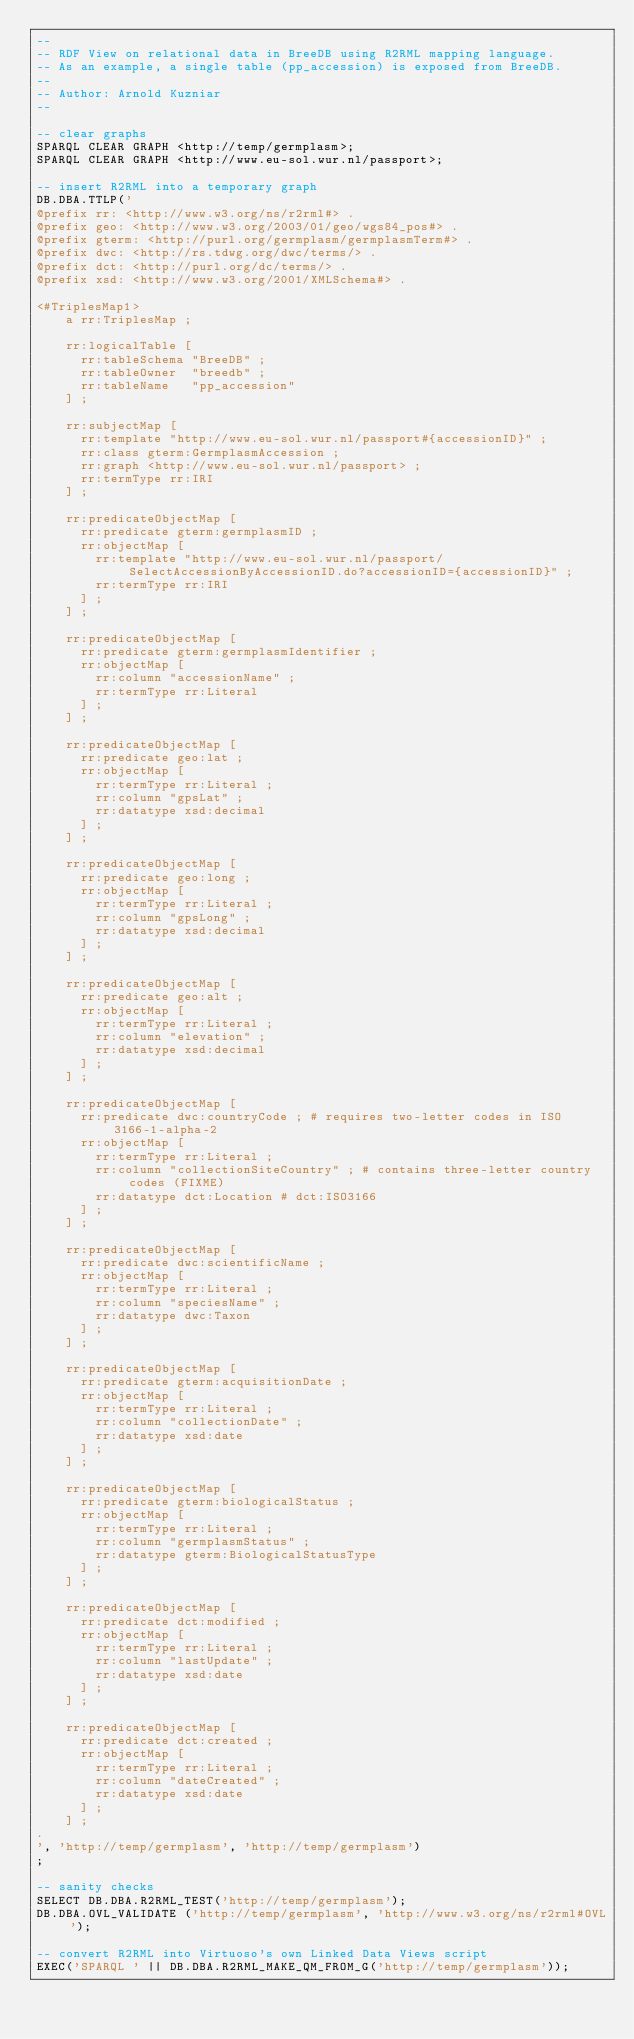Convert code to text. <code><loc_0><loc_0><loc_500><loc_500><_SQL_>--
-- RDF View on relational data in BreeDB using R2RML mapping language.
-- As an example, a single table (pp_accession) is exposed from BreeDB.
--
-- Author: Arnold Kuzniar
--

-- clear graphs
SPARQL CLEAR GRAPH <http://temp/germplasm>;
SPARQL CLEAR GRAPH <http://www.eu-sol.wur.nl/passport>;

-- insert R2RML into a temporary graph
DB.DBA.TTLP('
@prefix rr: <http://www.w3.org/ns/r2rml#> .
@prefix geo: <http://www.w3.org/2003/01/geo/wgs84_pos#> .
@prefix gterm: <http://purl.org/germplasm/germplasmTerm#> .
@prefix dwc: <http://rs.tdwg.org/dwc/terms/> .
@prefix dct: <http://purl.org/dc/terms/> .
@prefix xsd: <http://www.w3.org/2001/XMLSchema#> .

<#TriplesMap1>
    a rr:TriplesMap ;

    rr:logicalTable [
      rr:tableSchema "BreeDB" ;
      rr:tableOwner  "breedb" ;
      rr:tableName   "pp_accession"
    ] ;

    rr:subjectMap [
      rr:template "http://www.eu-sol.wur.nl/passport#{accessionID}" ;
      rr:class gterm:GermplasmAccession ;
      rr:graph <http://www.eu-sol.wur.nl/passport> ;
      rr:termType rr:IRI
    ] ;

    rr:predicateObjectMap [
      rr:predicate gterm:germplasmID ;
      rr:objectMap [
        rr:template "http://www.eu-sol.wur.nl/passport/SelectAccessionByAccessionID.do?accessionID={accessionID}" ;
        rr:termType rr:IRI
      ] ;
    ] ;

    rr:predicateObjectMap [
      rr:predicate gterm:germplasmIdentifier ;
      rr:objectMap [
        rr:column "accessionName" ;
        rr:termType rr:Literal
      ] ;
    ] ;

    rr:predicateObjectMap [
      rr:predicate geo:lat ;
      rr:objectMap [
        rr:termType rr:Literal ;
        rr:column "gpsLat" ;
        rr:datatype xsd:decimal
      ] ;
    ] ;

    rr:predicateObjectMap [
      rr:predicate geo:long ;
      rr:objectMap [
        rr:termType rr:Literal ;
        rr:column "gpsLong" ;
        rr:datatype xsd:decimal
      ] ;
    ] ;

    rr:predicateObjectMap [
      rr:predicate geo:alt ;
      rr:objectMap [
        rr:termType rr:Literal ;
        rr:column "elevation" ;
        rr:datatype xsd:decimal
      ] ;
    ] ;

    rr:predicateObjectMap [
      rr:predicate dwc:countryCode ; # requires two-letter codes in ISO 3166-1-alpha-2
      rr:objectMap [
        rr:termType rr:Literal ;
        rr:column "collectionSiteCountry" ; # contains three-letter country codes (FIXME)
        rr:datatype dct:Location # dct:ISO3166
      ] ;
    ] ;

    rr:predicateObjectMap [
      rr:predicate dwc:scientificName ;
      rr:objectMap [
        rr:termType rr:Literal ;
        rr:column "speciesName" ;
        rr:datatype dwc:Taxon
      ] ;
    ] ;

    rr:predicateObjectMap [
      rr:predicate gterm:acquisitionDate ;
      rr:objectMap [
        rr:termType rr:Literal ;
        rr:column "collectionDate" ;
        rr:datatype xsd:date
      ] ;
    ] ;

    rr:predicateObjectMap [
      rr:predicate gterm:biologicalStatus ;
      rr:objectMap [
        rr:termType rr:Literal ;
        rr:column "germplasmStatus" ;
        rr:datatype gterm:BiologicalStatusType
      ] ;
    ] ;

    rr:predicateObjectMap [
      rr:predicate dct:modified ;
      rr:objectMap [
        rr:termType rr:Literal ;
        rr:column "lastUpdate" ;
        rr:datatype xsd:date
      ] ;
    ] ;

    rr:predicateObjectMap [
      rr:predicate dct:created ;
      rr:objectMap [
        rr:termType rr:Literal ;
        rr:column "dateCreated" ;
        rr:datatype xsd:date
      ] ;
    ] ;
.
', 'http://temp/germplasm', 'http://temp/germplasm')
;

-- sanity checks
SELECT DB.DBA.R2RML_TEST('http://temp/germplasm');
DB.DBA.OVL_VALIDATE ('http://temp/germplasm', 'http://www.w3.org/ns/r2rml#OVL');

-- convert R2RML into Virtuoso's own Linked Data Views script
EXEC('SPARQL ' || DB.DBA.R2RML_MAKE_QM_FROM_G('http://temp/germplasm'));
</code> 